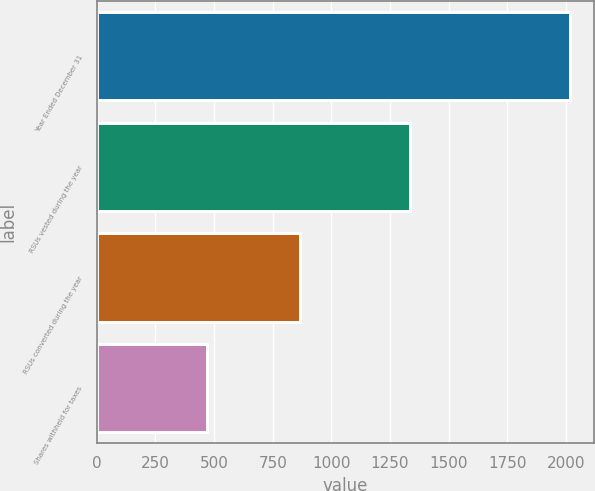Convert chart to OTSL. <chart><loc_0><loc_0><loc_500><loc_500><bar_chart><fcel>Year Ended December 31<fcel>RSUs vested during the year<fcel>RSUs converted during the year<fcel>Shares withheld for taxes<nl><fcel>2017<fcel>1337<fcel>865<fcel>472<nl></chart> 